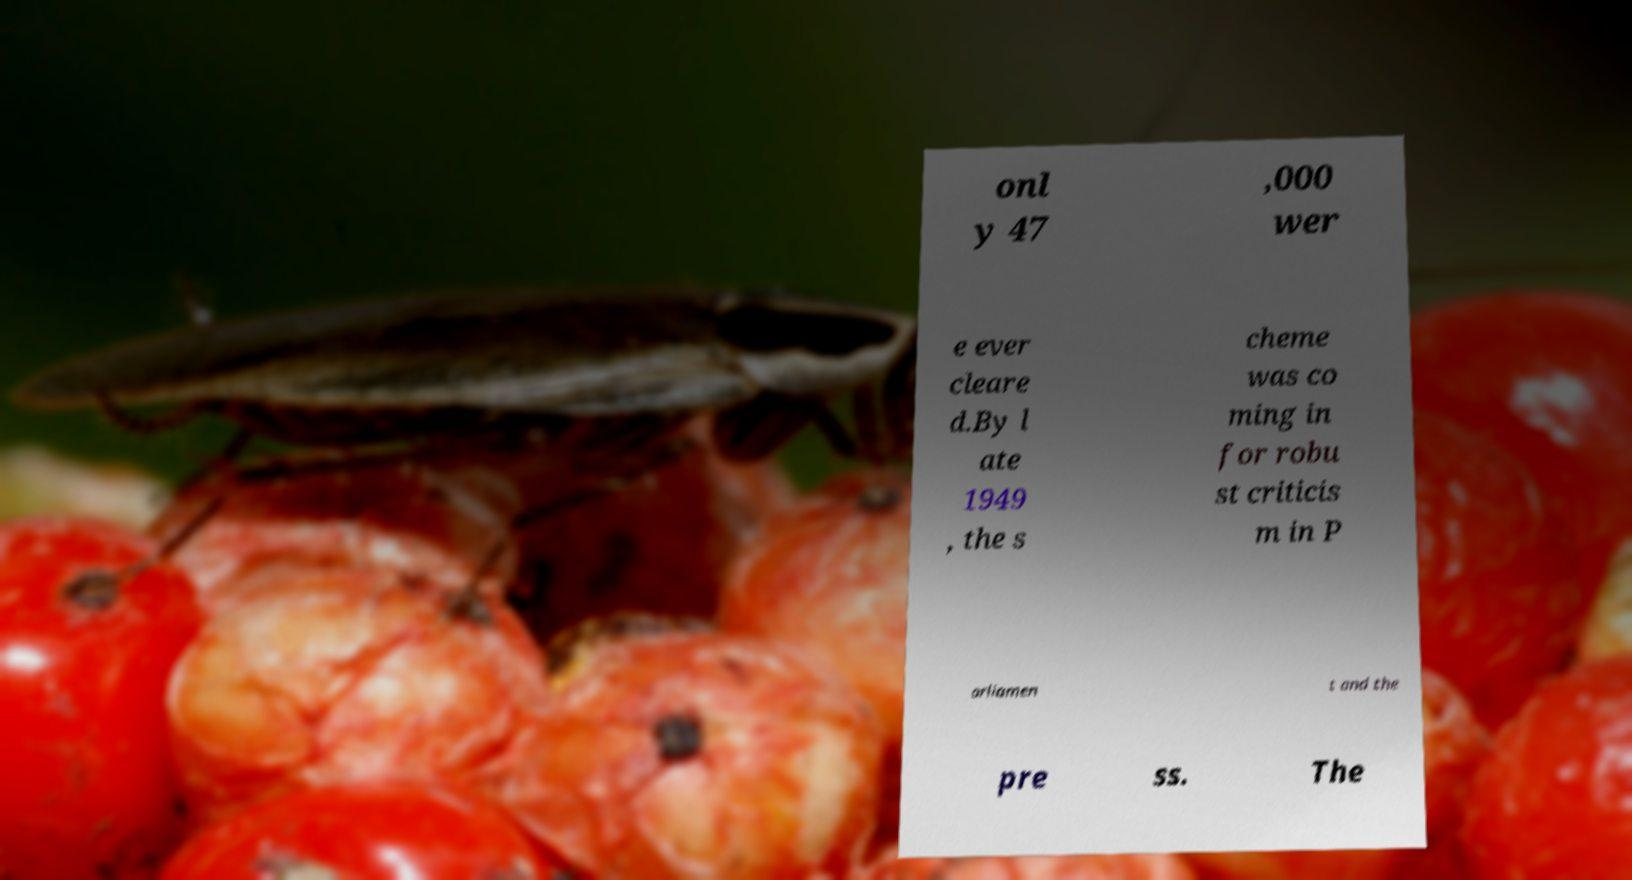For documentation purposes, I need the text within this image transcribed. Could you provide that? onl y 47 ,000 wer e ever cleare d.By l ate 1949 , the s cheme was co ming in for robu st criticis m in P arliamen t and the pre ss. The 